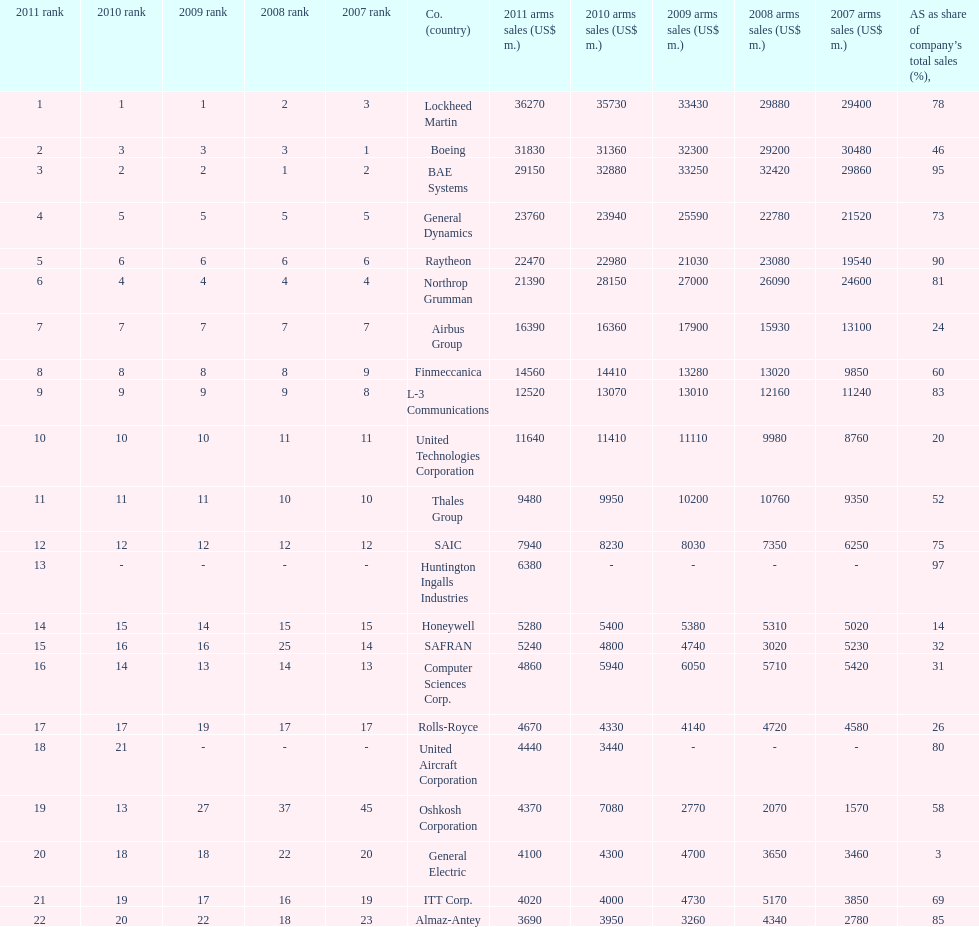Would you mind parsing the complete table? {'header': ['2011 rank', '2010 rank', '2009 rank', '2008 rank', '2007 rank', 'Co. (country)', '2011 arms sales (US$ m.)', '2010 arms sales (US$ m.)', '2009 arms sales (US$ m.)', '2008 arms sales (US$ m.)', '2007 arms sales (US$ m.)', 'AS as share of company’s total sales (%),'], 'rows': [['1', '1', '1', '2', '3', 'Lockheed Martin', '36270', '35730', '33430', '29880', '29400', '78'], ['2', '3', '3', '3', '1', 'Boeing', '31830', '31360', '32300', '29200', '30480', '46'], ['3', '2', '2', '1', '2', 'BAE Systems', '29150', '32880', '33250', '32420', '29860', '95'], ['4', '5', '5', '5', '5', 'General Dynamics', '23760', '23940', '25590', '22780', '21520', '73'], ['5', '6', '6', '6', '6', 'Raytheon', '22470', '22980', '21030', '23080', '19540', '90'], ['6', '4', '4', '4', '4', 'Northrop Grumman', '21390', '28150', '27000', '26090', '24600', '81'], ['7', '7', '7', '7', '7', 'Airbus Group', '16390', '16360', '17900', '15930', '13100', '24'], ['8', '8', '8', '8', '9', 'Finmeccanica', '14560', '14410', '13280', '13020', '9850', '60'], ['9', '9', '9', '9', '8', 'L-3 Communications', '12520', '13070', '13010', '12160', '11240', '83'], ['10', '10', '10', '11', '11', 'United Technologies Corporation', '11640', '11410', '11110', '9980', '8760', '20'], ['11', '11', '11', '10', '10', 'Thales Group', '9480', '9950', '10200', '10760', '9350', '52'], ['12', '12', '12', '12', '12', 'SAIC', '7940', '8230', '8030', '7350', '6250', '75'], ['13', '-', '-', '-', '-', 'Huntington Ingalls Industries', '6380', '-', '-', '-', '-', '97'], ['14', '15', '14', '15', '15', 'Honeywell', '5280', '5400', '5380', '5310', '5020', '14'], ['15', '16', '16', '25', '14', 'SAFRAN', '5240', '4800', '4740', '3020', '5230', '32'], ['16', '14', '13', '14', '13', 'Computer Sciences Corp.', '4860', '5940', '6050', '5710', '5420', '31'], ['17', '17', '19', '17', '17', 'Rolls-Royce', '4670', '4330', '4140', '4720', '4580', '26'], ['18', '21', '-', '-', '-', 'United Aircraft Corporation', '4440', '3440', '-', '-', '-', '80'], ['19', '13', '27', '37', '45', 'Oshkosh Corporation', '4370', '7080', '2770', '2070', '1570', '58'], ['20', '18', '18', '22', '20', 'General Electric', '4100', '4300', '4700', '3650', '3460', '3'], ['21', '19', '17', '16', '19', 'ITT Corp.', '4020', '4000', '4730', '5170', '3850', '69'], ['22', '20', '22', '18', '23', 'Almaz-Antey', '3690', '3950', '3260', '4340', '2780', '85']]} In 2010, who has the least amount of sales? United Aircraft Corporation. 